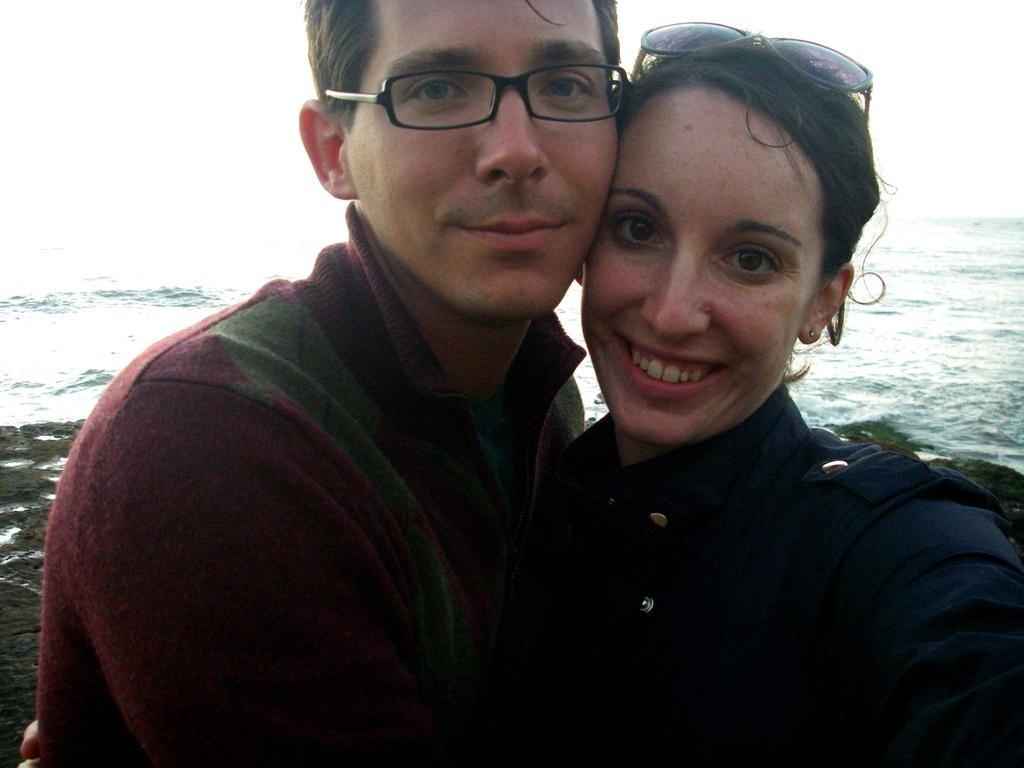Can you describe this image briefly? In the image in the center we can see two persons were standing and they were smiling,which we can see on their faces. In the background we can see water. 